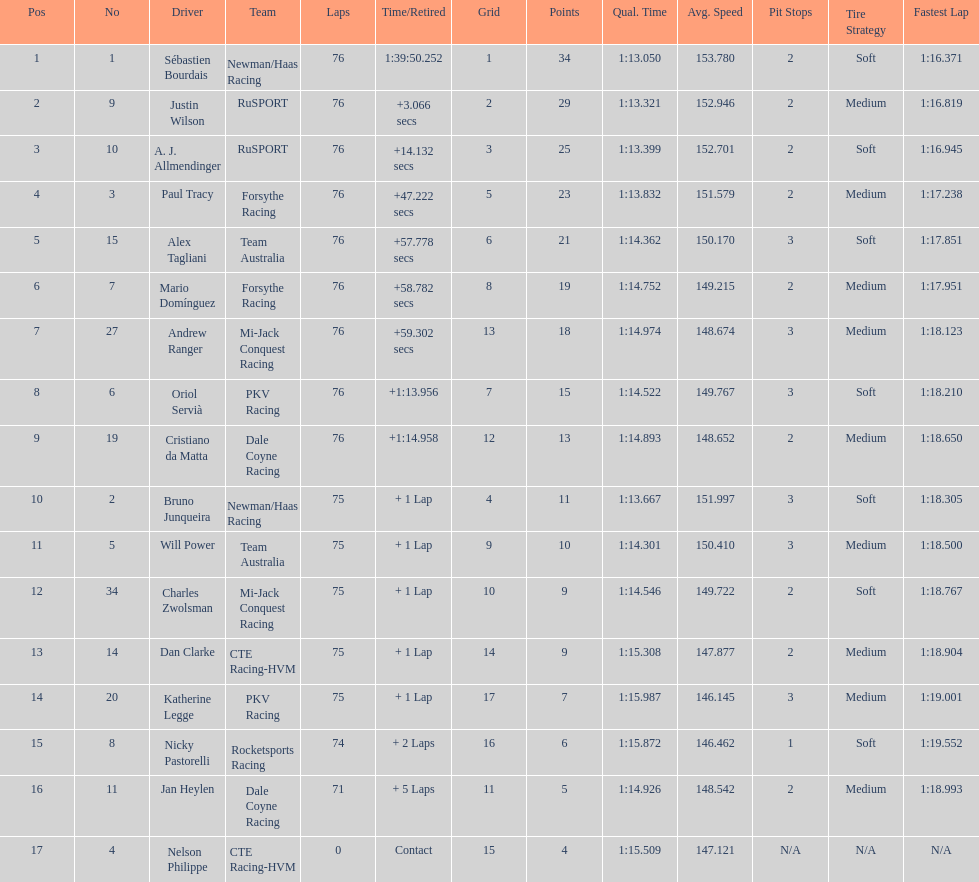Which driver has the least amount of points? Nelson Philippe. 